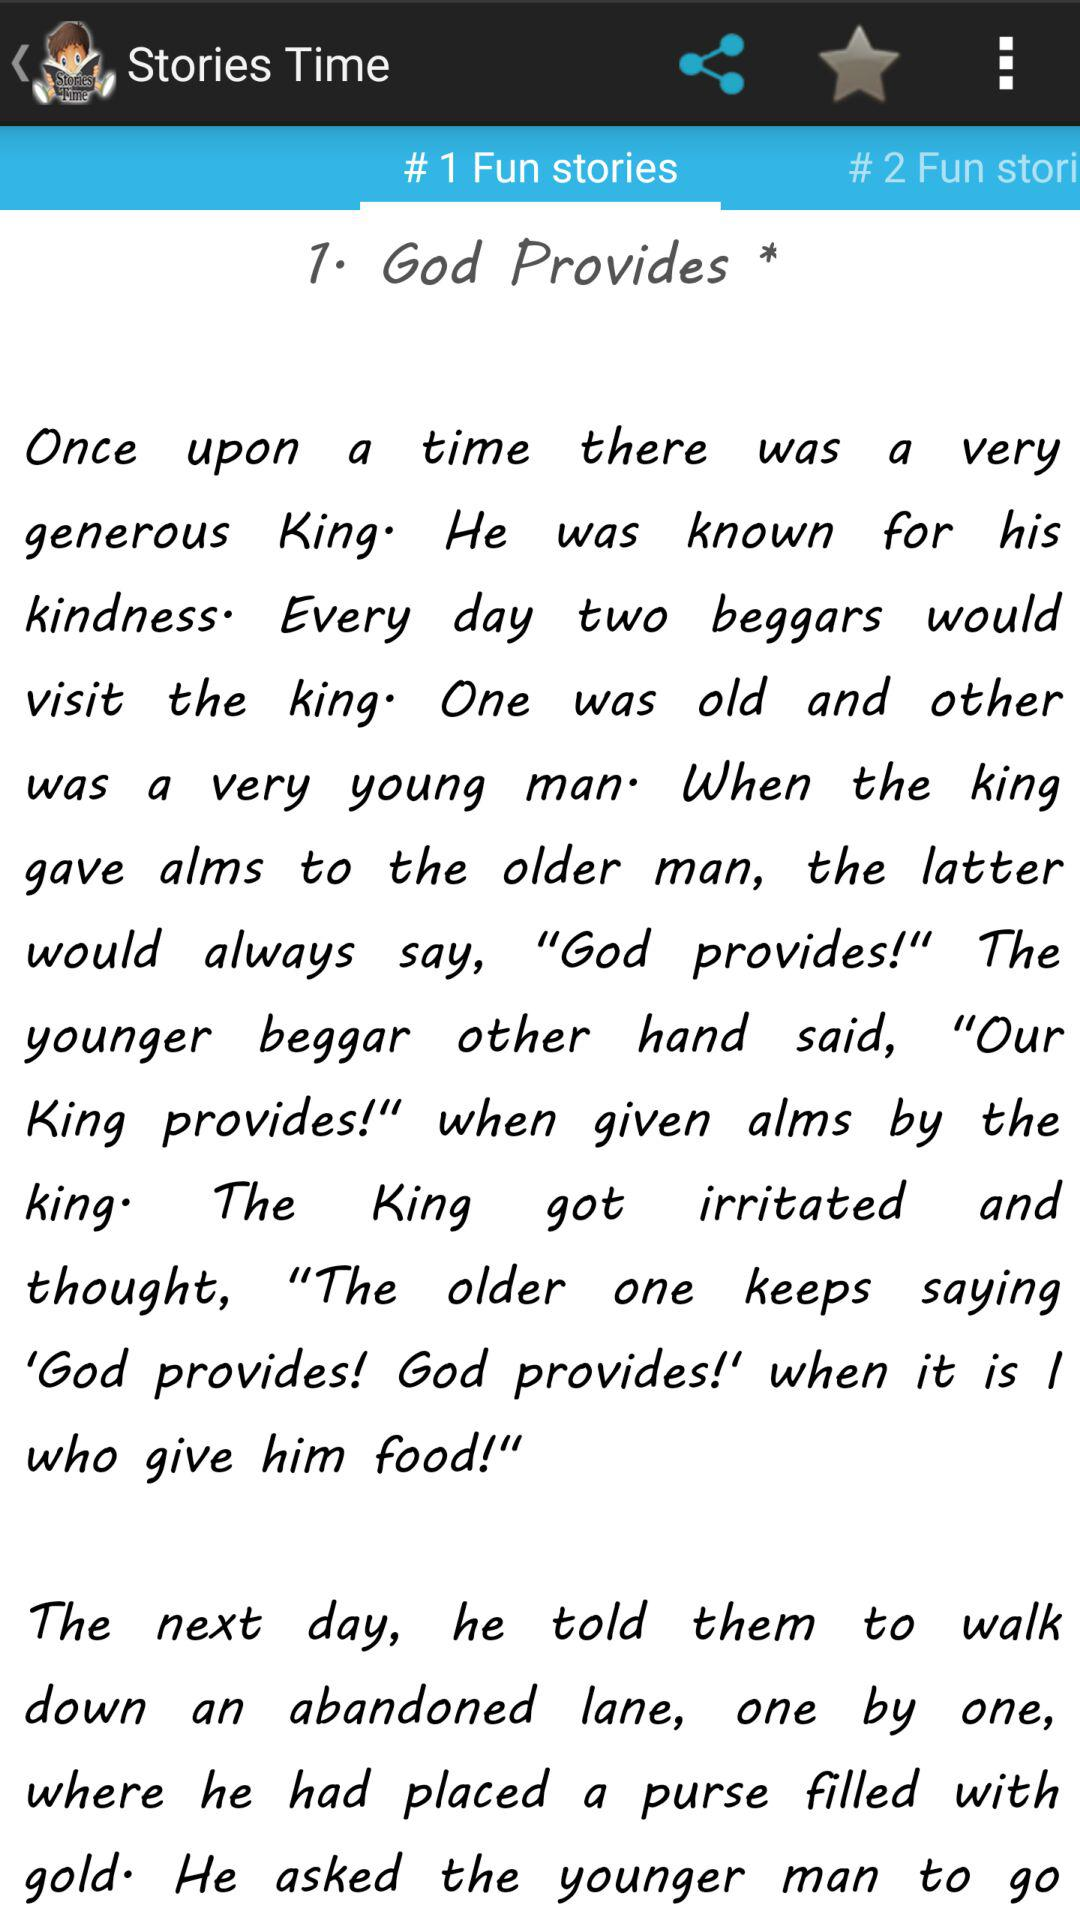What is the name of Story 1? The name of Story 1 is "God Provides". 